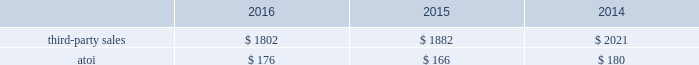Third-party sales for the engineered products and solutions segment improved 7% ( 7 % ) in 2016 compared with 2015 , primarily attributable to higher third-party sales of the two acquired businesses ( $ 457 ) , primarily related to the aerospace end market , and increased demand from the industrial gas turbine end market , partially offset by lower volumes in the oil and gas end market and commercial transportation end market as well as pricing pressures in aerospace .
Third-party sales for this segment improved 27% ( 27 % ) in 2015 compared with 2014 , largely attributable to the third-party sales ( $ 1310 ) of the three acquired businesses ( see above ) , and higher volumes in this segment 2019s legacy businesses , both of which were primarily related to the aerospace end market .
These positive impacts were slightly offset by unfavorable foreign currency movements , principally driven by a weaker euro .
Atoi for the engineered products and solutions segment increased $ 47 , or 8% ( 8 % ) , in 2016 compared with 2015 , primarily related to net productivity improvements across all businesses as well as the volume increase from both the rti acquisition and organic revenue growth , partially offset by a lower margin product mix and pricing pressures in the aerospace end market .
Atoi for this segment increased $ 16 , or 3% ( 3 % ) , in 2015 compared with 2014 , principally the result of net productivity improvements across most businesses , a positive contribution from acquisitions , and overall higher volumes in this segment 2019s legacy businesses .
These positive impacts were partially offset by unfavorable price and product mix , higher costs related to growth projects , and net unfavorable foreign currency movements , primarily related to a weaker euro .
In 2017 , demand in the commercial aerospace end market is expected to remain strong , driven by the ramp up of new aerospace engine platforms , somewhat offset by continued customer destocking and engine ramp-up challenges .
Demand in the defense end market is expected to grow due to the continuing ramp-up of certain aerospace programs .
Additionally , net productivity improvements are anticipated while pricing pressure across all markets is likely to continue .
Transportation and construction solutions .
The transportation and construction solutions segment produces products that are used mostly in the nonresidential building and construction and commercial transportation end markets .
Such products include integrated aluminum structural systems , architectural extrusions , and forged aluminum commercial vehicle wheels , which are sold both directly to customers and through distributors .
A small part of this segment also produces aluminum products for the industrial products end market .
Generally , the sales and costs and expenses of this segment are transacted in the local currency of the respective operations , which are primarily the u.s .
Dollar , the euro , and the brazilian real .
Third-party sales for the transportation and construction solutions segment decreased 4% ( 4 % ) in 2016 compared with 2015 , primarily driven by lower demand from the north american commercial transportation end market , which was partially offset by rising demand from the building and construction end market .
Third-party sales for this segment decreased 7% ( 7 % ) in 2015 compared with 2014 , primarily driven by unfavorable foreign currency movements , principally caused by a weaker euro and brazilian real , and lower volume related to the building and construction end market , somewhat offset by higher volume related to the commercial transportation end market .
Atoi for the transportation and construction solutions segment increased $ 10 , or 6% ( 6 % ) , in 2016 compared with 2015 , principally driven by net productivity improvements across all businesses and growth in the building and construction segment , partially offset by lower demand in the north american heavy duty truck and brazilian markets. .
Considering the years 2015-2016 , what was the variation observed in the growth of the atoi in the transportation and construction solutions engineered products and solutions segments? 
Rationale: it is the difference between the percentual growth of both segments' atoi .
Computations: (8% - 6%)
Answer: 0.02. 